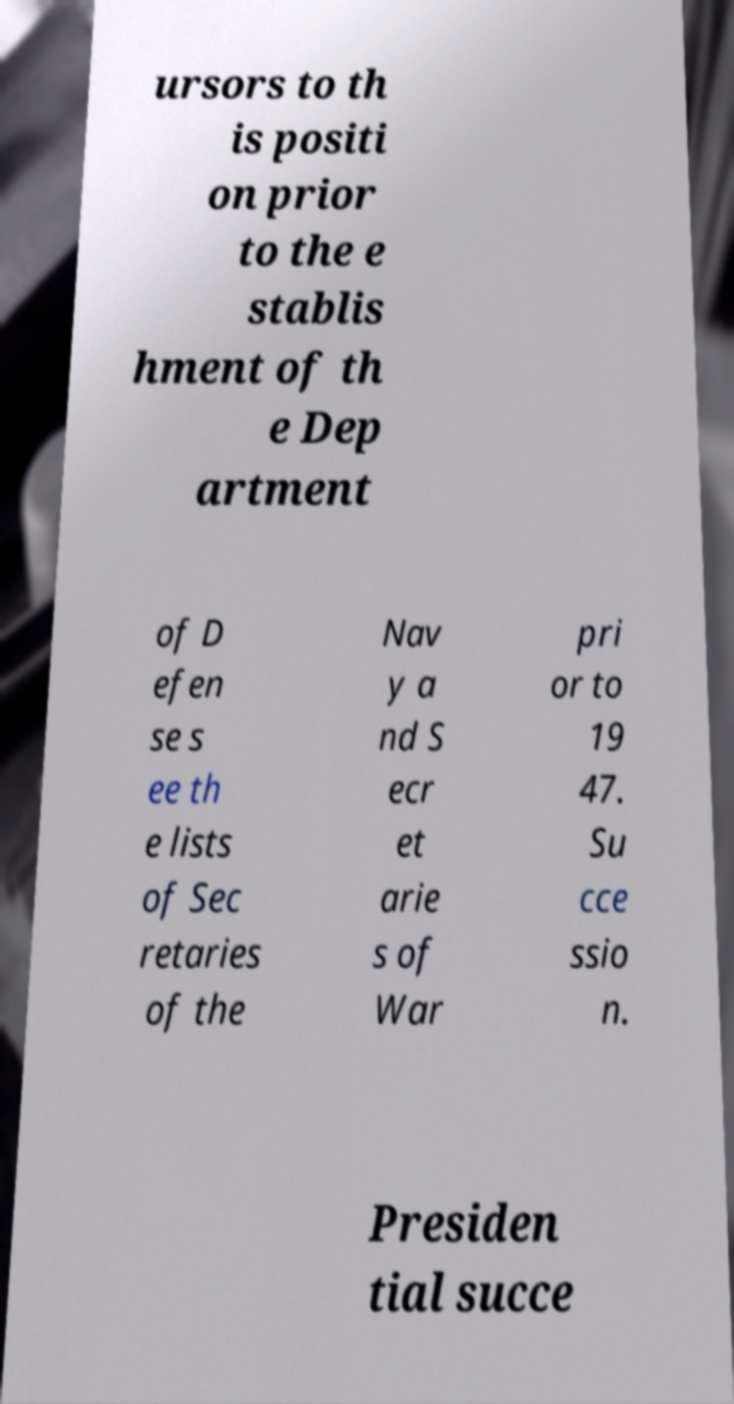What messages or text are displayed in this image? I need them in a readable, typed format. ursors to th is positi on prior to the e stablis hment of th e Dep artment of D efen se s ee th e lists of Sec retaries of the Nav y a nd S ecr et arie s of War pri or to 19 47. Su cce ssio n. Presiden tial succe 